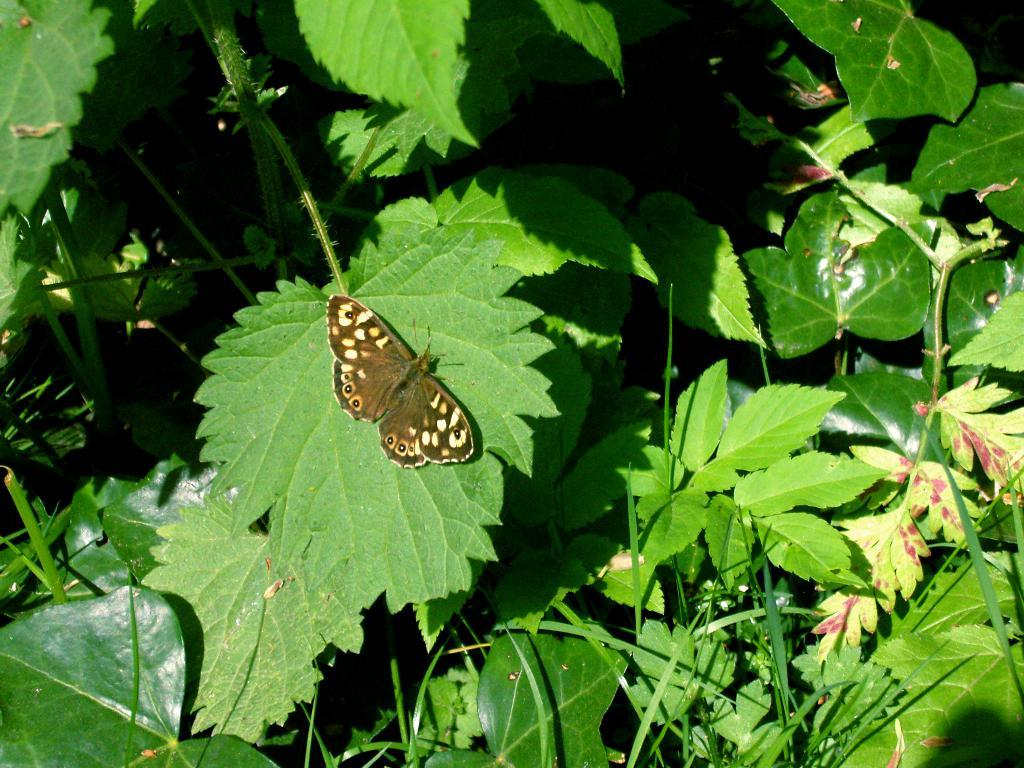What type of insect can be seen in the picture? There is a butterfly in the picture. What other natural elements are present in the image? There are leaves in the picture. What type of vacation is the butterfly planning in the image? There is no indication in the image that the butterfly is planning a vacation, as butterflies do not plan vacations. 